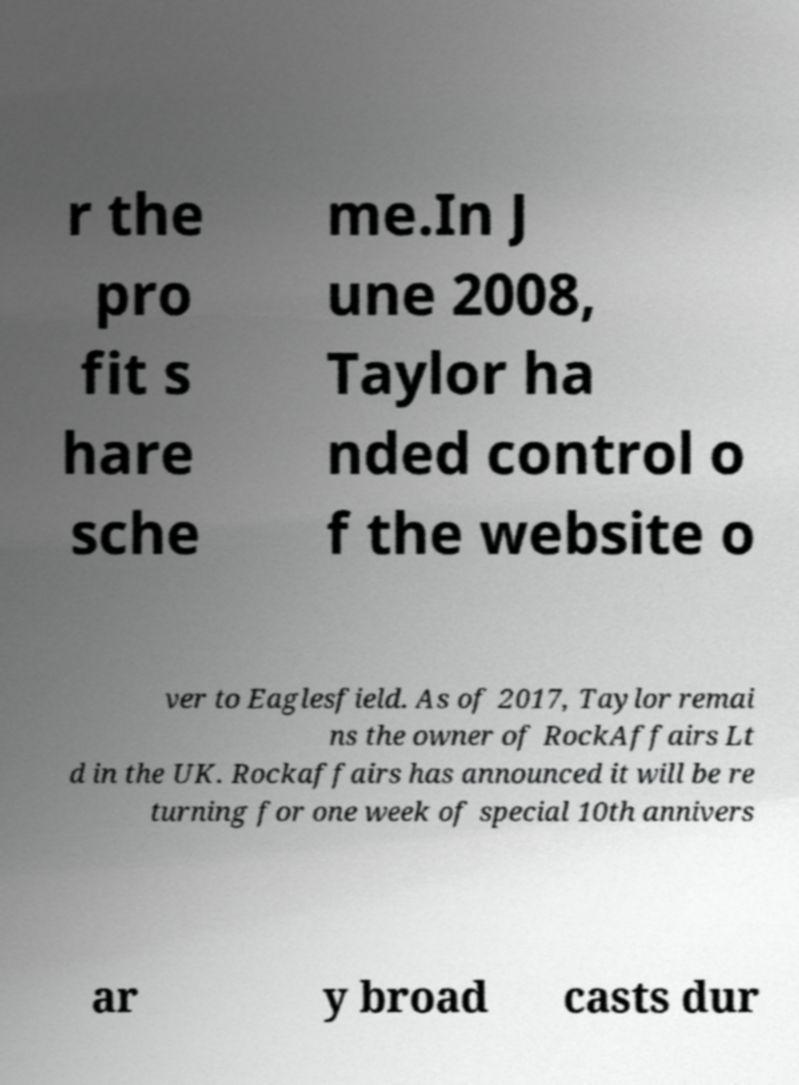Could you extract and type out the text from this image? r the pro fit s hare sche me.In J une 2008, Taylor ha nded control o f the website o ver to Eaglesfield. As of 2017, Taylor remai ns the owner of RockAffairs Lt d in the UK. Rockaffairs has announced it will be re turning for one week of special 10th annivers ar y broad casts dur 